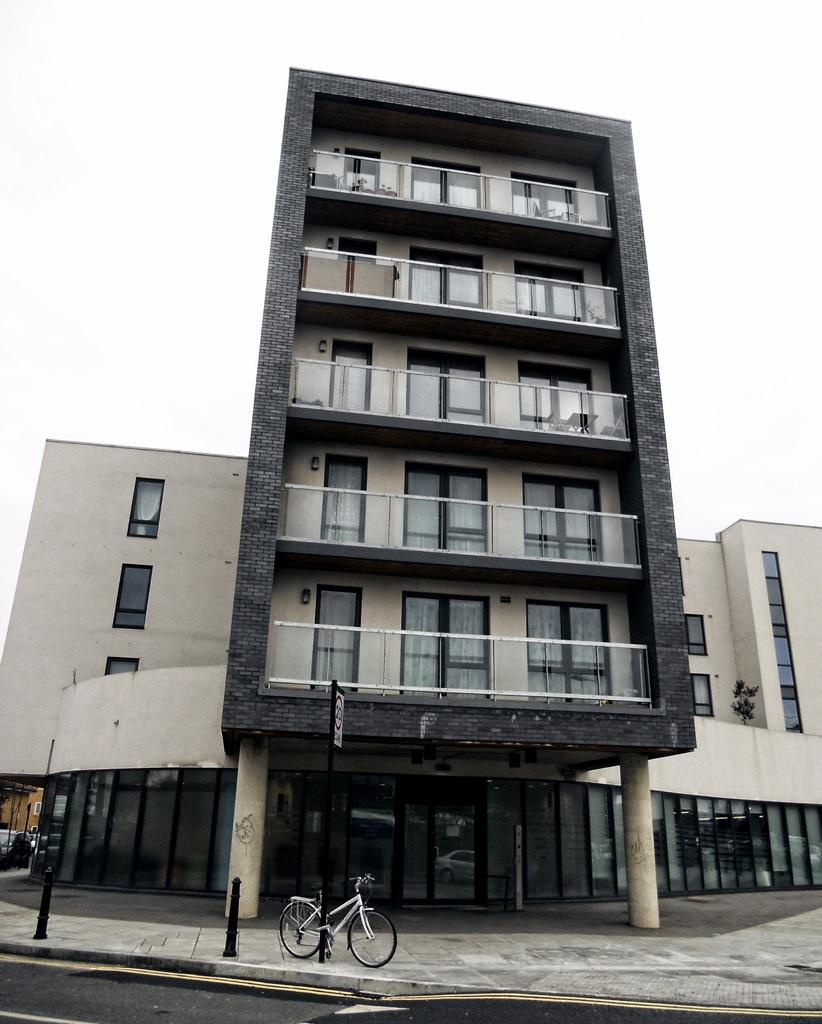What type of structure is present in the image? There is a building in the image. What features can be observed on the building? The building has many doors and windows. Is there any transportation visible in the image? Yes, there is a bicycle in front of the building on a footpath. What can be seen above the building? The sky is visible above the building. How many people are exchanging train tickets in the image? There is no train or ticket exchange present in the image; it features a building with a bicycle in front. 